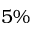Convert formula to latex. <formula><loc_0><loc_0><loc_500><loc_500>5 \%</formula> 